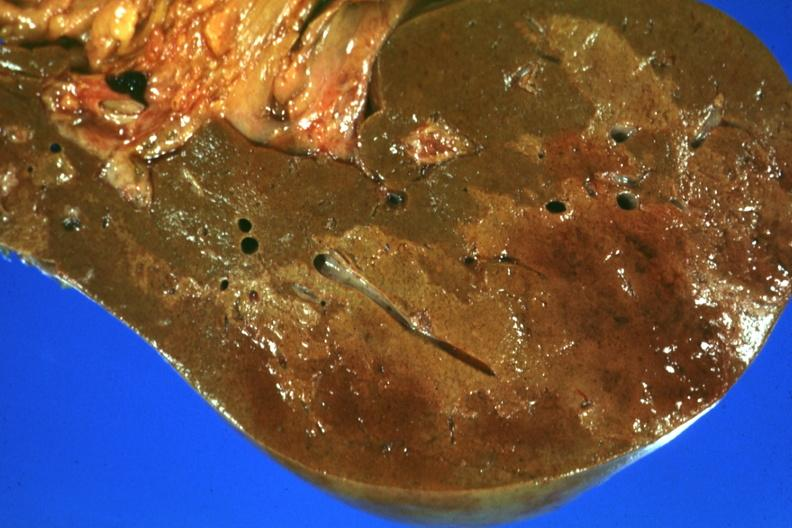what is present?
Answer the question using a single word or phrase. Hepatobiliary 